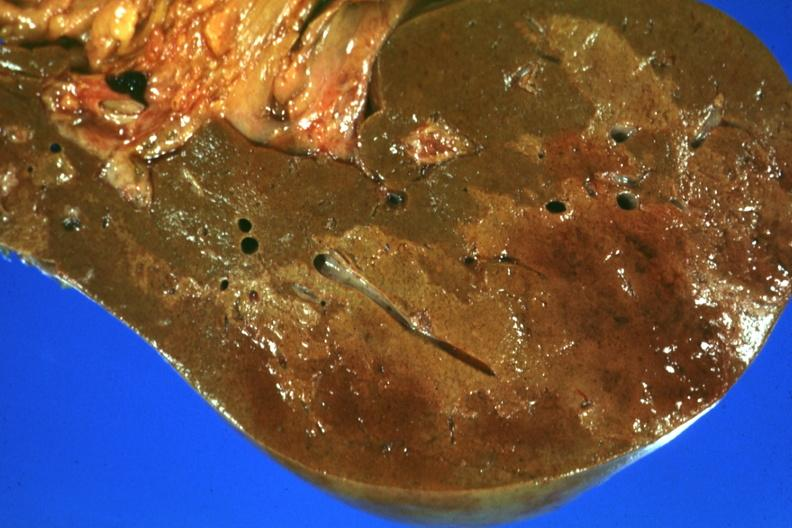what is present?
Answer the question using a single word or phrase. Hepatobiliary 